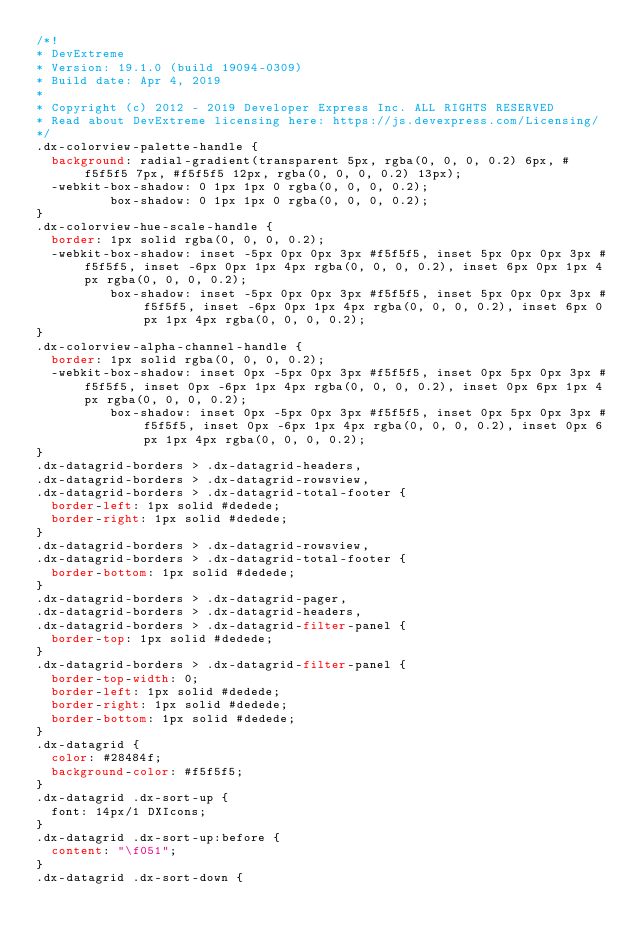Convert code to text. <code><loc_0><loc_0><loc_500><loc_500><_CSS_>/*!
* DevExtreme
* Version: 19.1.0 (build 19094-0309)
* Build date: Apr 4, 2019
*
* Copyright (c) 2012 - 2019 Developer Express Inc. ALL RIGHTS RESERVED
* Read about DevExtreme licensing here: https://js.devexpress.com/Licensing/
*/
.dx-colorview-palette-handle {
  background: radial-gradient(transparent 5px, rgba(0, 0, 0, 0.2) 6px, #f5f5f5 7px, #f5f5f5 12px, rgba(0, 0, 0, 0.2) 13px);
  -webkit-box-shadow: 0 1px 1px 0 rgba(0, 0, 0, 0.2);
          box-shadow: 0 1px 1px 0 rgba(0, 0, 0, 0.2);
}
.dx-colorview-hue-scale-handle {
  border: 1px solid rgba(0, 0, 0, 0.2);
  -webkit-box-shadow: inset -5px 0px 0px 3px #f5f5f5, inset 5px 0px 0px 3px #f5f5f5, inset -6px 0px 1px 4px rgba(0, 0, 0, 0.2), inset 6px 0px 1px 4px rgba(0, 0, 0, 0.2);
          box-shadow: inset -5px 0px 0px 3px #f5f5f5, inset 5px 0px 0px 3px #f5f5f5, inset -6px 0px 1px 4px rgba(0, 0, 0, 0.2), inset 6px 0px 1px 4px rgba(0, 0, 0, 0.2);
}
.dx-colorview-alpha-channel-handle {
  border: 1px solid rgba(0, 0, 0, 0.2);
  -webkit-box-shadow: inset 0px -5px 0px 3px #f5f5f5, inset 0px 5px 0px 3px #f5f5f5, inset 0px -6px 1px 4px rgba(0, 0, 0, 0.2), inset 0px 6px 1px 4px rgba(0, 0, 0, 0.2);
          box-shadow: inset 0px -5px 0px 3px #f5f5f5, inset 0px 5px 0px 3px #f5f5f5, inset 0px -6px 1px 4px rgba(0, 0, 0, 0.2), inset 0px 6px 1px 4px rgba(0, 0, 0, 0.2);
}
.dx-datagrid-borders > .dx-datagrid-headers,
.dx-datagrid-borders > .dx-datagrid-rowsview,
.dx-datagrid-borders > .dx-datagrid-total-footer {
  border-left: 1px solid #dedede;
  border-right: 1px solid #dedede;
}
.dx-datagrid-borders > .dx-datagrid-rowsview,
.dx-datagrid-borders > .dx-datagrid-total-footer {
  border-bottom: 1px solid #dedede;
}
.dx-datagrid-borders > .dx-datagrid-pager,
.dx-datagrid-borders > .dx-datagrid-headers,
.dx-datagrid-borders > .dx-datagrid-filter-panel {
  border-top: 1px solid #dedede;
}
.dx-datagrid-borders > .dx-datagrid-filter-panel {
  border-top-width: 0;
  border-left: 1px solid #dedede;
  border-right: 1px solid #dedede;
  border-bottom: 1px solid #dedede;
}
.dx-datagrid {
  color: #28484f;
  background-color: #f5f5f5;
}
.dx-datagrid .dx-sort-up {
  font: 14px/1 DXIcons;
}
.dx-datagrid .dx-sort-up:before {
  content: "\f051";
}
.dx-datagrid .dx-sort-down {</code> 